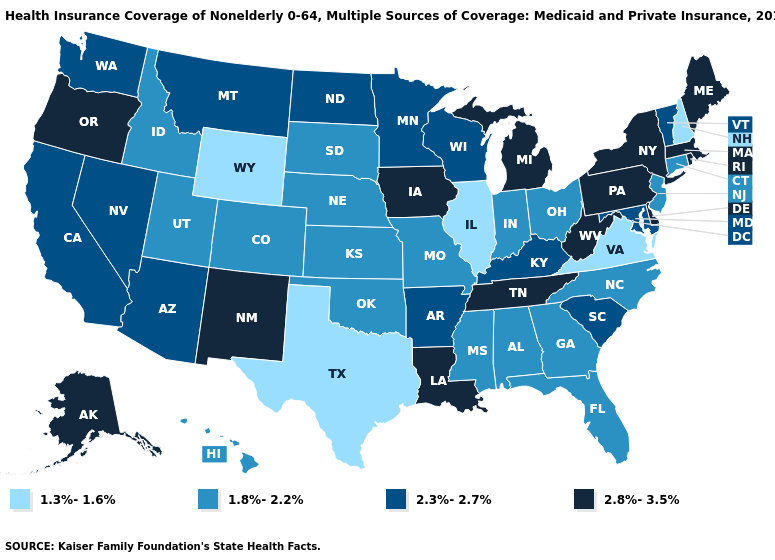Does the first symbol in the legend represent the smallest category?
Be succinct. Yes. What is the highest value in the South ?
Concise answer only. 2.8%-3.5%. Among the states that border New Hampshire , which have the highest value?
Be succinct. Maine, Massachusetts. What is the value of Hawaii?
Answer briefly. 1.8%-2.2%. Is the legend a continuous bar?
Keep it brief. No. Name the states that have a value in the range 2.3%-2.7%?
Answer briefly. Arizona, Arkansas, California, Kentucky, Maryland, Minnesota, Montana, Nevada, North Dakota, South Carolina, Vermont, Washington, Wisconsin. Name the states that have a value in the range 2.8%-3.5%?
Keep it brief. Alaska, Delaware, Iowa, Louisiana, Maine, Massachusetts, Michigan, New Mexico, New York, Oregon, Pennsylvania, Rhode Island, Tennessee, West Virginia. Is the legend a continuous bar?
Concise answer only. No. What is the value of Missouri?
Quick response, please. 1.8%-2.2%. Does Utah have a higher value than Wyoming?
Quick response, please. Yes. Name the states that have a value in the range 2.8%-3.5%?
Be succinct. Alaska, Delaware, Iowa, Louisiana, Maine, Massachusetts, Michigan, New Mexico, New York, Oregon, Pennsylvania, Rhode Island, Tennessee, West Virginia. Does Nebraska have a lower value than Arkansas?
Be succinct. Yes. Does North Carolina have a lower value than Maine?
Write a very short answer. Yes. Name the states that have a value in the range 2.8%-3.5%?
Quick response, please. Alaska, Delaware, Iowa, Louisiana, Maine, Massachusetts, Michigan, New Mexico, New York, Oregon, Pennsylvania, Rhode Island, Tennessee, West Virginia. Among the states that border Vermont , does New Hampshire have the lowest value?
Concise answer only. Yes. 